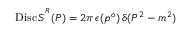<formula> <loc_0><loc_0><loc_500><loc_500>D i s c \, S ^ { ^ { R } } ( P ) = 2 \pi \, \epsilon ( p ^ { o } ) \, \delta ( P ^ { 2 } - m ^ { 2 } ) \,</formula> 